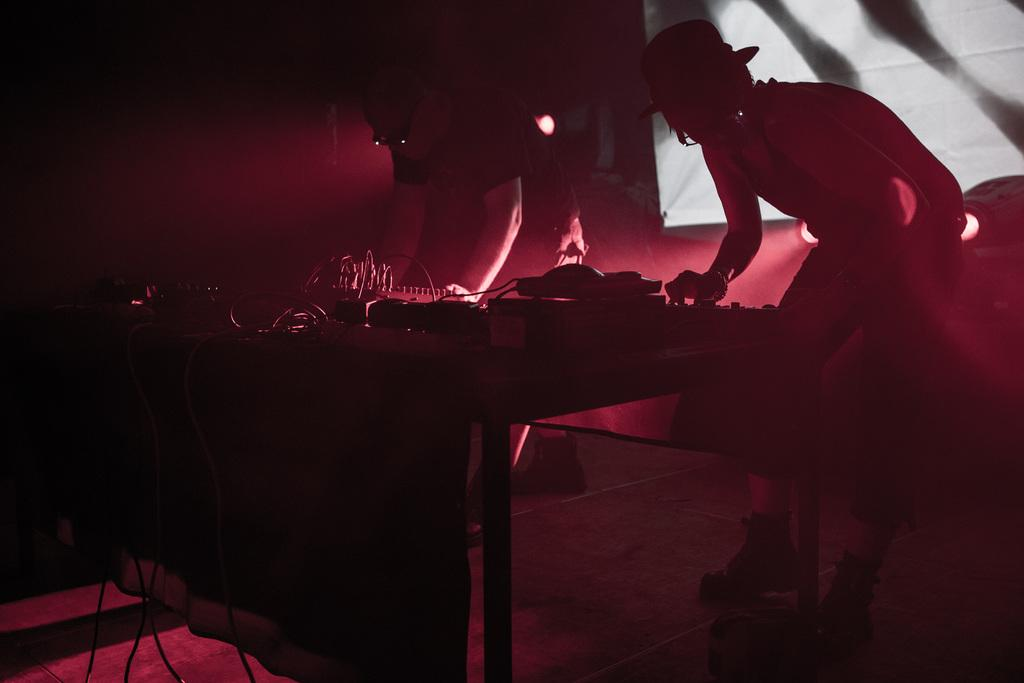What can be seen running through the image? There are wires in the image. What is present on a surface in the image? There are objects on a table in the image. How many people are visible in the image? There are two people standing in the image. What is providing illumination in the image? There are lights in the image. What else can be seen in the image besides the mentioned elements? There are other objects in the image. Is there a sail visible in the image? There is no sail present in the image. Can you see a throne in the image? There is no throne present in the image. 